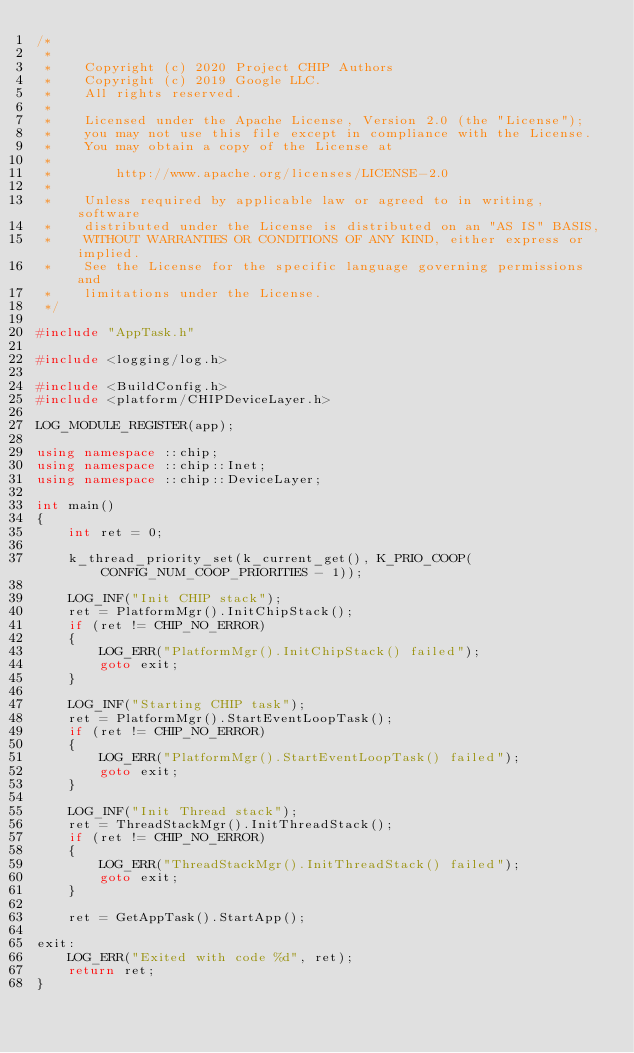Convert code to text. <code><loc_0><loc_0><loc_500><loc_500><_C++_>/*
 *
 *    Copyright (c) 2020 Project CHIP Authors
 *    Copyright (c) 2019 Google LLC.
 *    All rights reserved.
 *
 *    Licensed under the Apache License, Version 2.0 (the "License");
 *    you may not use this file except in compliance with the License.
 *    You may obtain a copy of the License at
 *
 *        http://www.apache.org/licenses/LICENSE-2.0
 *
 *    Unless required by applicable law or agreed to in writing, software
 *    distributed under the License is distributed on an "AS IS" BASIS,
 *    WITHOUT WARRANTIES OR CONDITIONS OF ANY KIND, either express or implied.
 *    See the License for the specific language governing permissions and
 *    limitations under the License.
 */

#include "AppTask.h"

#include <logging/log.h>

#include <BuildConfig.h>
#include <platform/CHIPDeviceLayer.h>

LOG_MODULE_REGISTER(app);

using namespace ::chip;
using namespace ::chip::Inet;
using namespace ::chip::DeviceLayer;

int main()
{
    int ret = 0;

    k_thread_priority_set(k_current_get(), K_PRIO_COOP(CONFIG_NUM_COOP_PRIORITIES - 1));

    LOG_INF("Init CHIP stack");
    ret = PlatformMgr().InitChipStack();
    if (ret != CHIP_NO_ERROR)
    {
        LOG_ERR("PlatformMgr().InitChipStack() failed");
        goto exit;
    }

    LOG_INF("Starting CHIP task");
    ret = PlatformMgr().StartEventLoopTask();
    if (ret != CHIP_NO_ERROR)
    {
        LOG_ERR("PlatformMgr().StartEventLoopTask() failed");
        goto exit;
    }

    LOG_INF("Init Thread stack");
    ret = ThreadStackMgr().InitThreadStack();
    if (ret != CHIP_NO_ERROR)
    {
        LOG_ERR("ThreadStackMgr().InitThreadStack() failed");
        goto exit;
    }

    ret = GetAppTask().StartApp();

exit:
    LOG_ERR("Exited with code %d", ret);
    return ret;
}
</code> 